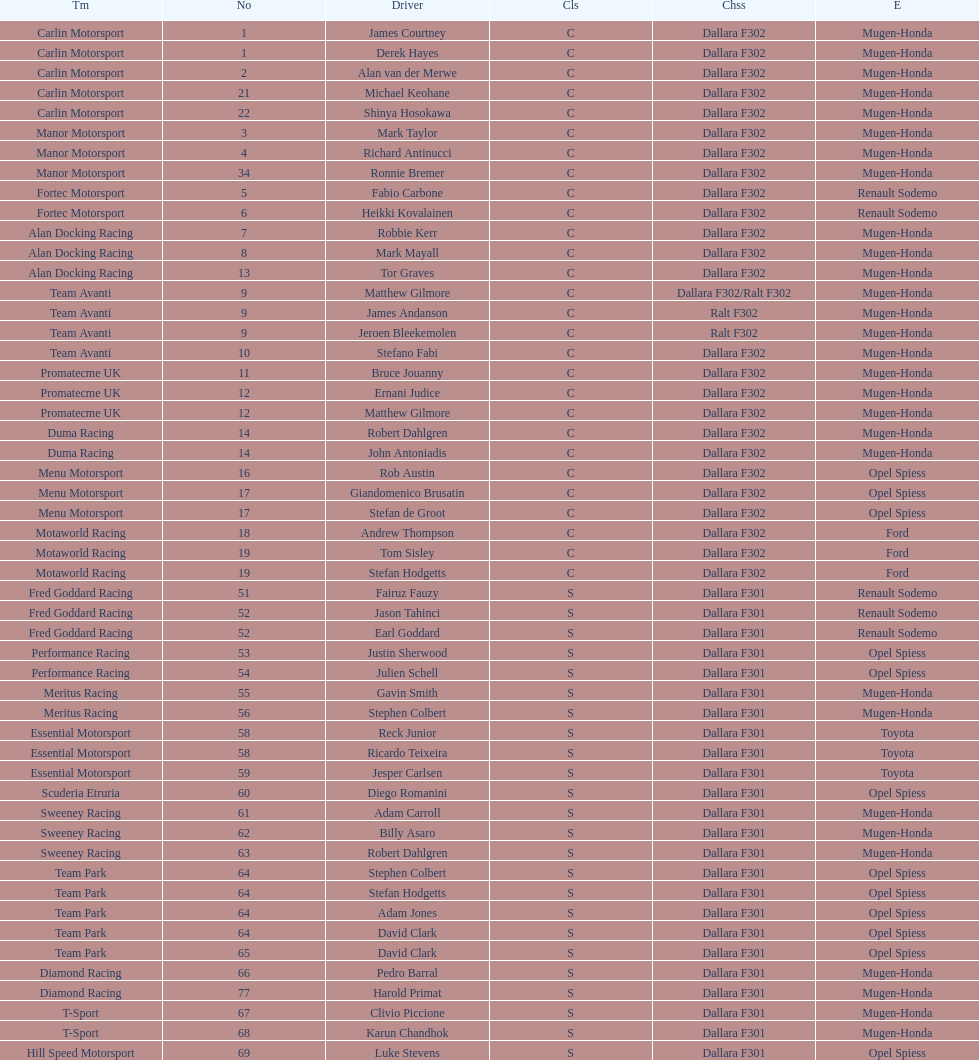Which engine was used the most by teams this season? Mugen-Honda. 